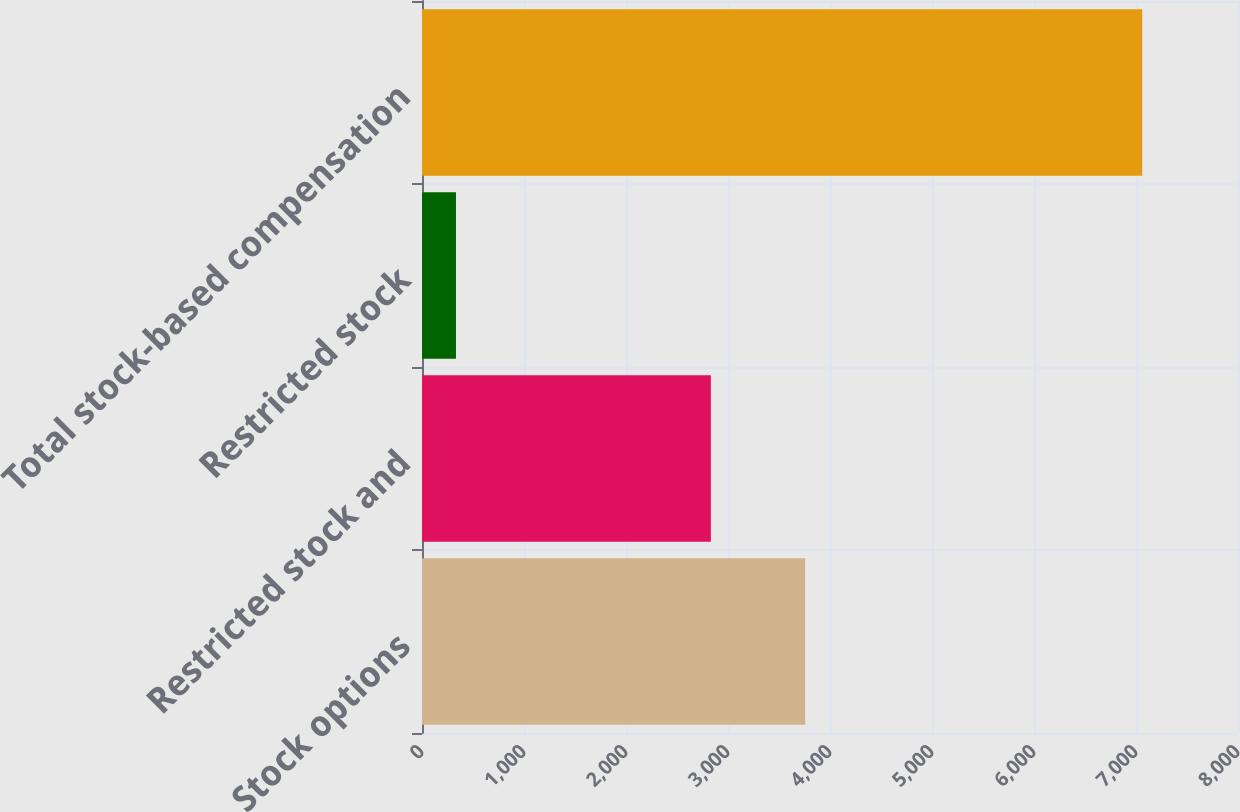Convert chart to OTSL. <chart><loc_0><loc_0><loc_500><loc_500><bar_chart><fcel>Stock options<fcel>Restricted stock and<fcel>Restricted stock<fcel>Total stock-based compensation<nl><fcel>3757<fcel>2832<fcel>333<fcel>7061<nl></chart> 